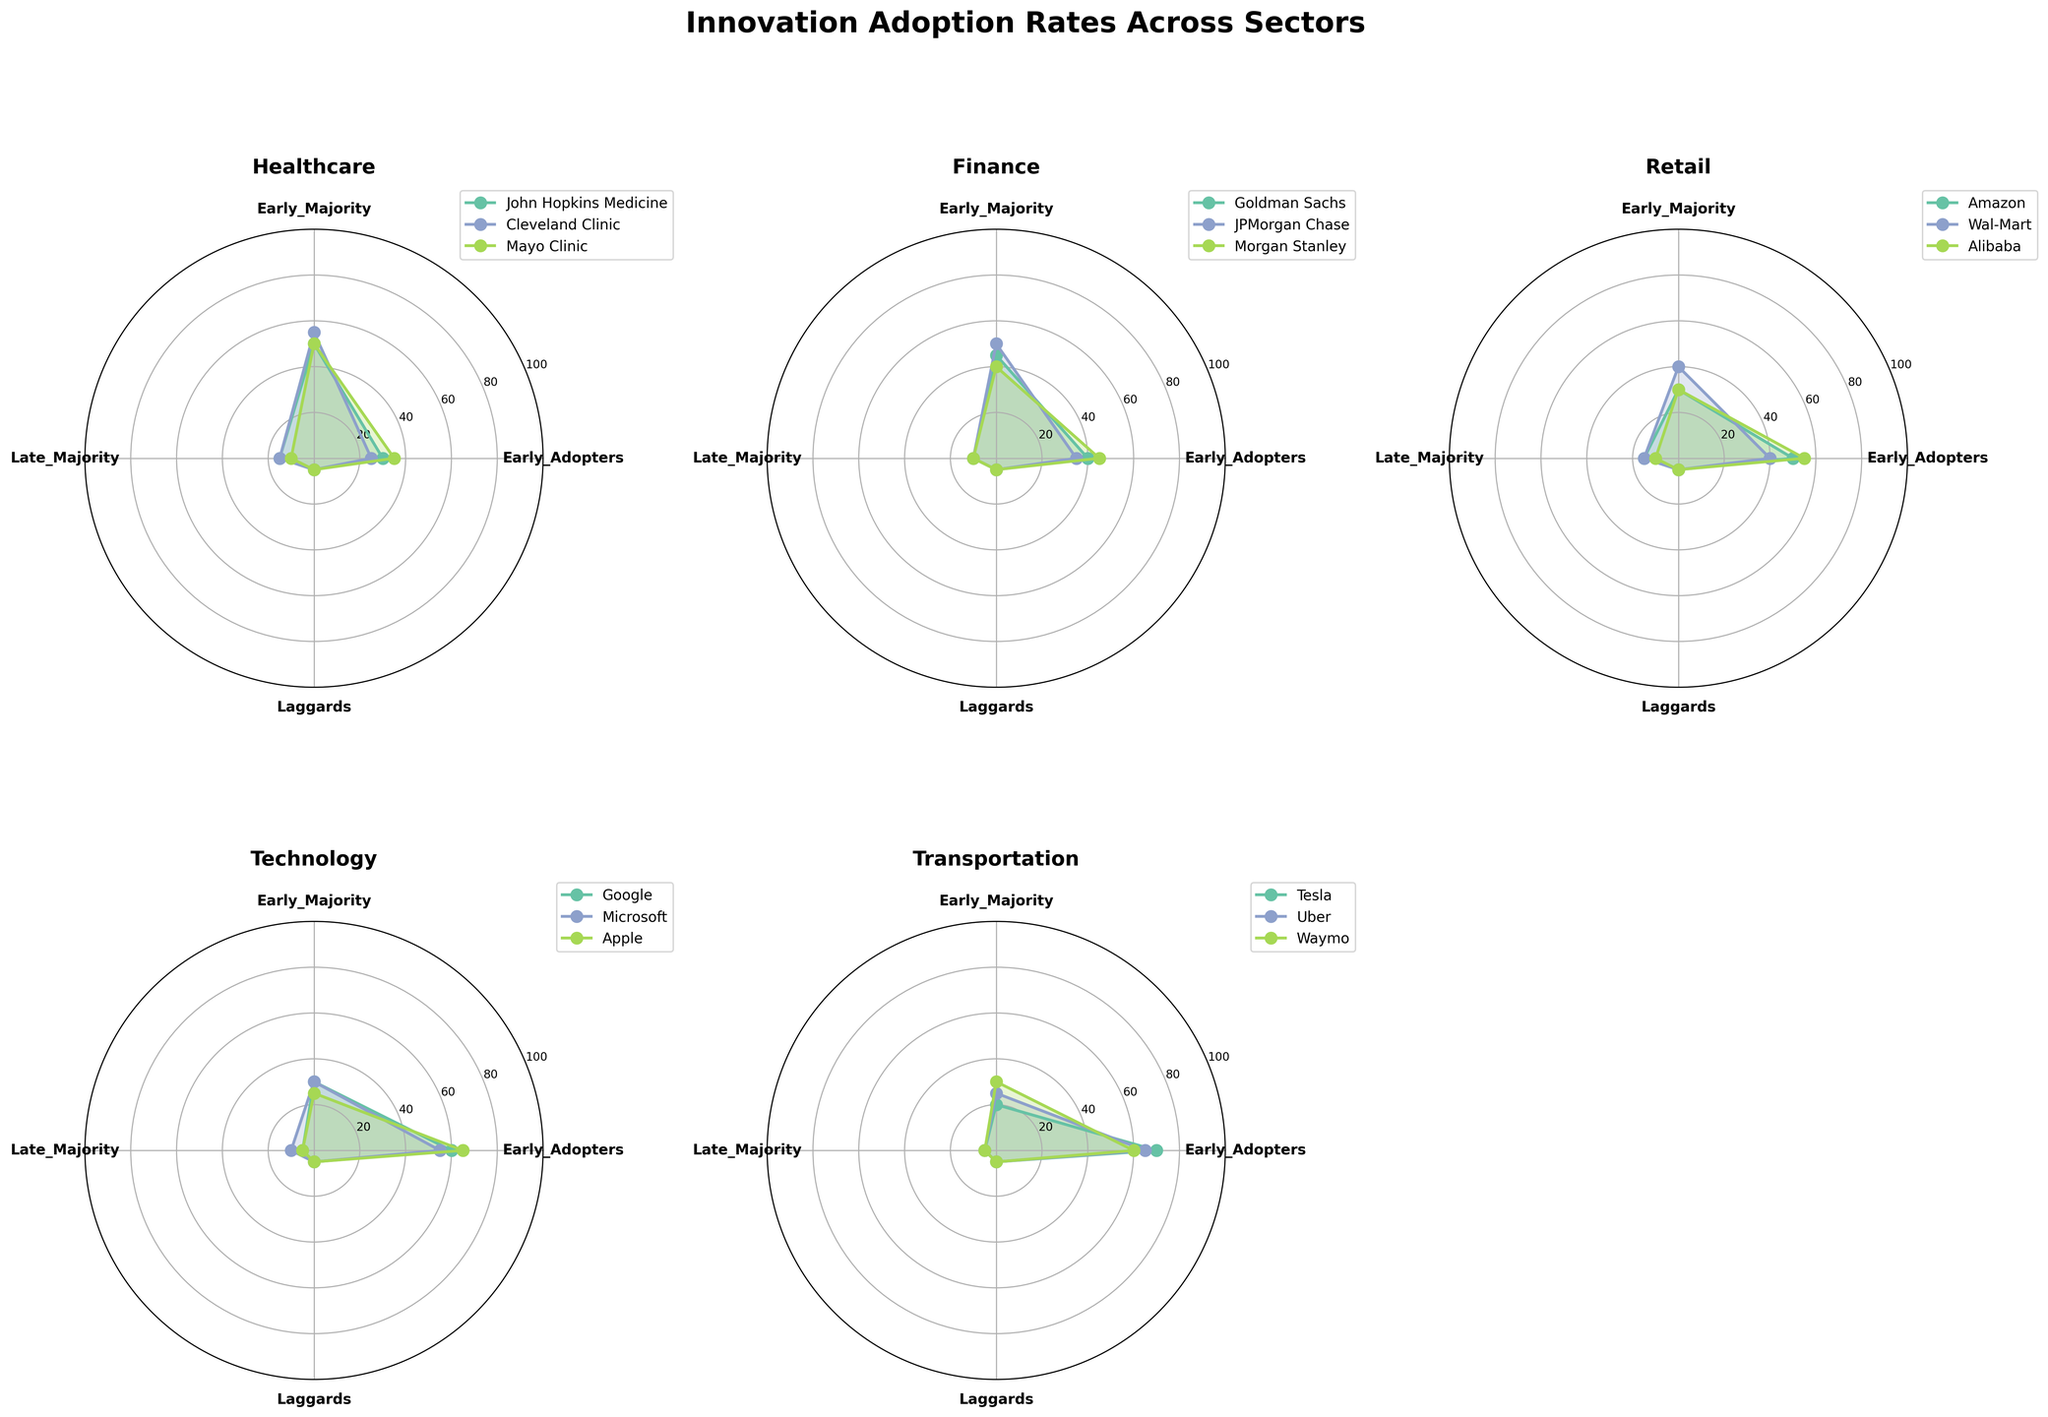What's the sector with the highest average percentage of Early Adopters? First, we look at each sector's Early Adopters percentages and calculate their average. For example, Healthcare has (30+25+35)/3 = 30% average Early Adopters, Finance has (40+35+45)/3 = 40%, Retail has (50+40+55)/3 = 48.3%, Technology has (60+55+65)/3 = 60%, and Transportation has (70+65+60)/3 = 65%. Comparing all sectors, Transportation has the highest average percentage of Early Adopters.
Answer: Transportation Which entities have the highest and lowest values for Early Majority within the Finance sector? For the Finance sector, we check the values of Early Majority: Goldman Sachs has 45%, JPMorgan Chase has 50%, and Morgan Stanley has 40%. Among these, JPMorgan Chase has the highest value, and Morgan Stanley has the lowest.
Answer: JPMorgan Chase (highest), Morgan Stanley (lowest) How does the adoption pattern in Healthcare compare between Mayo Clinic and Cleveland Clinic? We observe the radar charts for both Mayo Clinic and Cleveland Clinic in the Healthcare sector. Mayo Clinic has values of 35% Early Adopters, 50% Early Majority, 10% Late Majority, and 5% Laggards. Cleveland Clinic has 25% Early Adopters, 55% Early Majority, 15% Late Majority, and 5% Laggards. Mayo Clinic has higher Early Adopters and lower Early Majority and Late Majority compared to Cleveland Clinic, while Laggards are the same.
Answer: Mayo Clinic has more Early Adopters than Cleveland Clinic and slightly lower Early Majority and Late Majority What's the sum of the values for Late Majority and Laggards for Apple? Looking at Technology sector data, for Apple, the values for Late Majority and Laggards are 5% and 5%, respectively. Summing them up, we get 5 + 5 = 10%.
Answer: 10% What is the common trend of Laggards across all sectors? By examining the radar charts for each sector and the values of Laggards, we notice that the percentage of Laggards is consistently 5% across all the entities and sectors shown. This indicates a uniform low adoption rate amongst Laggards regardless of the sector.
Answer: 5% Which sector has the largest disparity in Early Adopters among its entities? We compare the range (max - min) of Early Adopters' values within sectors. Healthcare ranges from 25% to 35% (10% disparity), Finance from 35% to 45% (10%), Retail from 40% to 55% (15%), Technology from 55% to 65% (10%), and Transportation from 60% to 70% (10%). Thus, Retail has the largest disparity at 15%.
Answer: Retail How do the Early Majority rates of Amazon and Google compare? Amazon is in the Retail sector with an Early Majority rate of 30%. Google is in the Technology sector with an Early Majority rate of 30%. So, both Amazon and Google have the same Early Majority rate.
Answer: Same (30%) Which entity in the Transportation sector has the highest Early Adopters percentage? In the Transportation sector, the percentages of Early Adopters are: Tesla (70%), Uber (65%), Waymo (60%). Tesla has the highest percentage of Early Adopters.
Answer: Tesla What is the overall pattern of technology sector entities’ values compared to Healthcare? Both sectors consist of three entities. Technology has generally higher Early Adopters (65%, 60%, 55%) compared to Healthcare (35%, 30%, 25%). Technology entities have lower Late Majority and similar Laggards in comparison to Healthcare, indicating a faster overall innovation adoption.
Answer: Higher Early Adopters, lower Late Majority, similar Laggards 